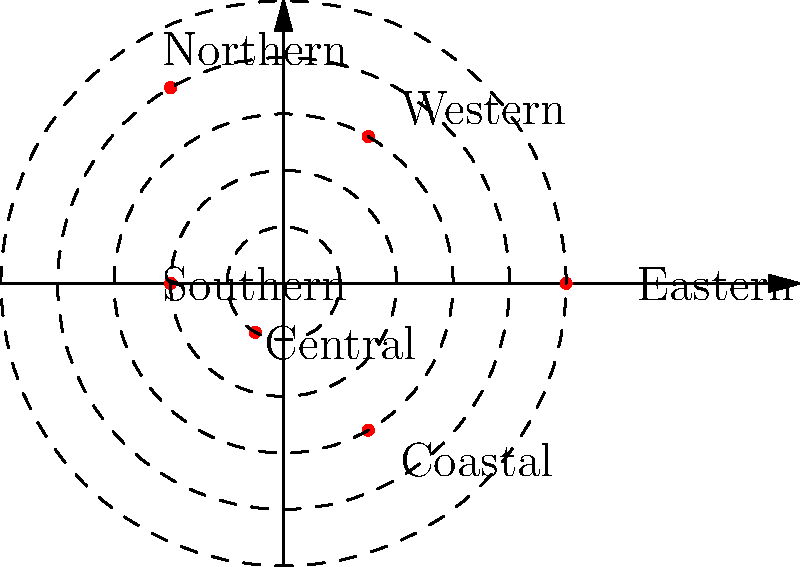The polar coordinate plot shows the distribution of kangaroo populations across different regions of Australia. Each point represents a region, with the angle indicating its location and the radius representing the relative population size. Which region has the largest kangaroo population, and what is its approximate relative population size? To answer this question, we need to follow these steps:

1. Understand that in polar coordinates, the distance from the center (radius) represents the relative population size.
2. Identify all the points on the plot and their corresponding regions.
3. Compare the radii of all points to find the largest one.

Looking at the plot, we can see six points representing different regions:

- Eastern: angle 0°, radius ≈ 5
- Western: angle 60°, radius ≈ 3
- Northern: angle 120°, radius ≈ 4
- Southern: angle 180°, radius ≈ 2
- Central: angle 240°, radius ≈ 1
- Coastal: angle 300°, radius ≈ 3

The point with the largest radius is at 0°, which corresponds to the Eastern region. Its radius is approximately 5 units.

Therefore, the Eastern region has the largest kangaroo population with a relative population size of about 5.
Answer: Eastern region, 5 